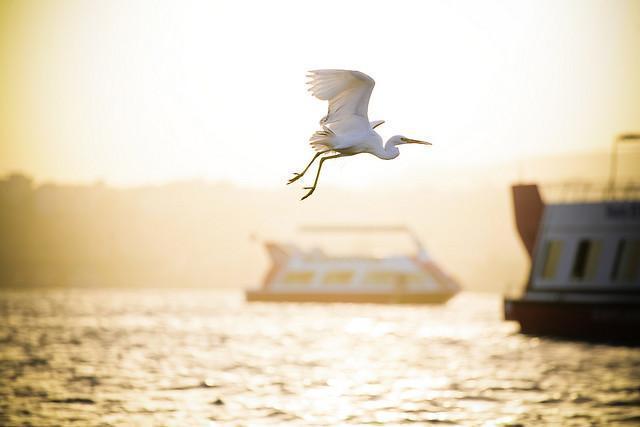How many birds are in the picture?
Give a very brief answer. 1. How many boats can you see?
Give a very brief answer. 2. How many people are wearing glasses?
Give a very brief answer. 0. 